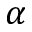<formula> <loc_0><loc_0><loc_500><loc_500>\alpha</formula> 